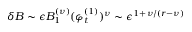<formula> <loc_0><loc_0><loc_500><loc_500>\delta B \sim \epsilon B _ { 1 } ^ { ( \nu ) } ( \varphi _ { t } ^ { ( 1 ) } ) ^ { \nu } \sim \epsilon ^ { 1 + \nu / ( r - \nu ) }</formula> 